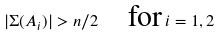<formula> <loc_0><loc_0><loc_500><loc_500>| \Sigma ( A _ { i } ) | > n / 2 \quad \text {for} \, i = 1 , 2</formula> 